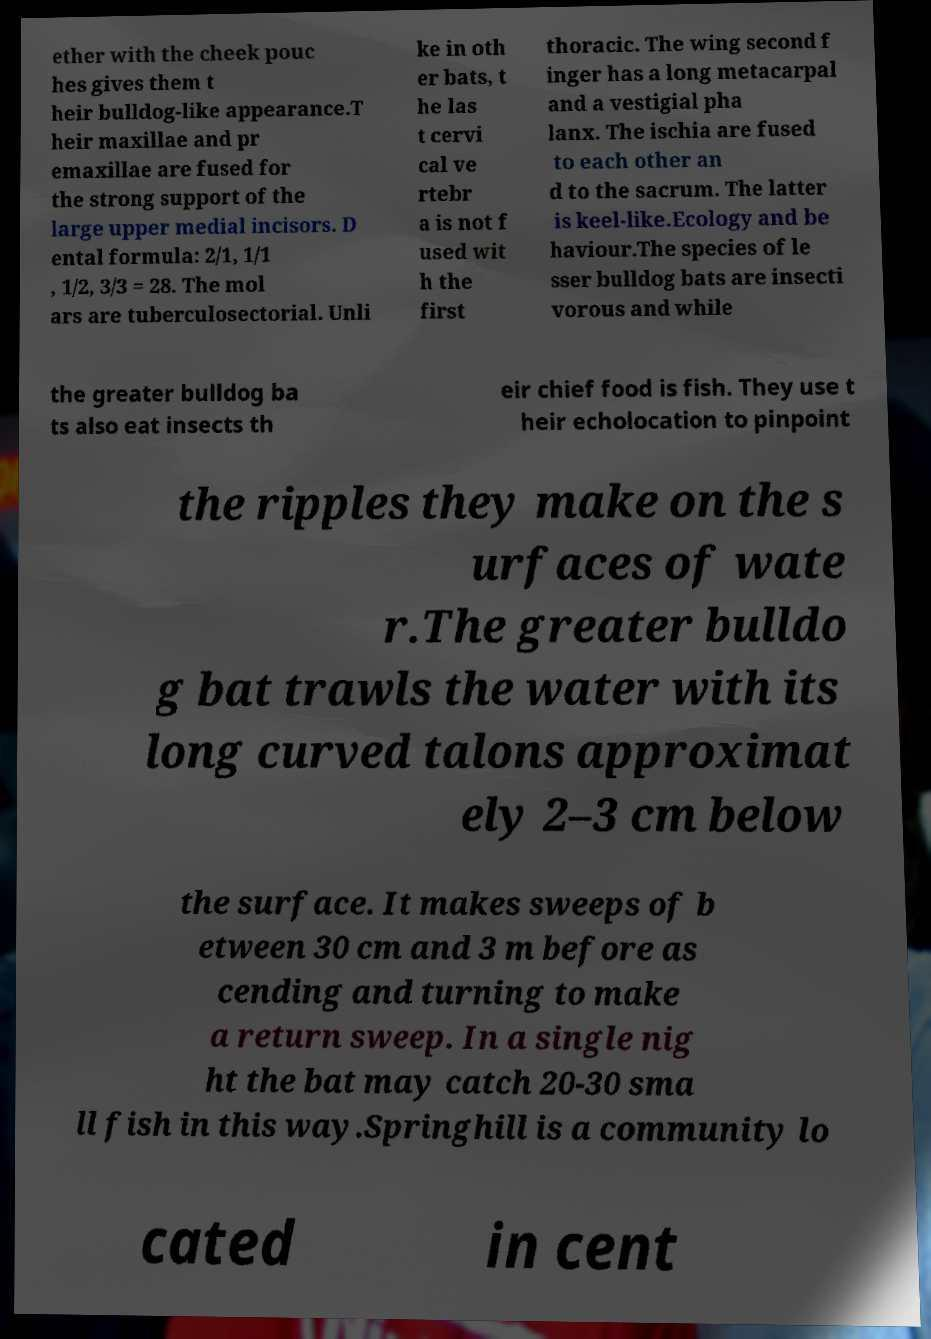Can you accurately transcribe the text from the provided image for me? ether with the cheek pouc hes gives them t heir bulldog-like appearance.T heir maxillae and pr emaxillae are fused for the strong support of the large upper medial incisors. D ental formula: 2/1, 1/1 , 1/2, 3/3 = 28. The mol ars are tuberculosectorial. Unli ke in oth er bats, t he las t cervi cal ve rtebr a is not f used wit h the first thoracic. The wing second f inger has a long metacarpal and a vestigial pha lanx. The ischia are fused to each other an d to the sacrum. The latter is keel-like.Ecology and be haviour.The species of le sser bulldog bats are insecti vorous and while the greater bulldog ba ts also eat insects th eir chief food is fish. They use t heir echolocation to pinpoint the ripples they make on the s urfaces of wate r.The greater bulldo g bat trawls the water with its long curved talons approximat ely 2–3 cm below the surface. It makes sweeps of b etween 30 cm and 3 m before as cending and turning to make a return sweep. In a single nig ht the bat may catch 20-30 sma ll fish in this way.Springhill is a community lo cated in cent 